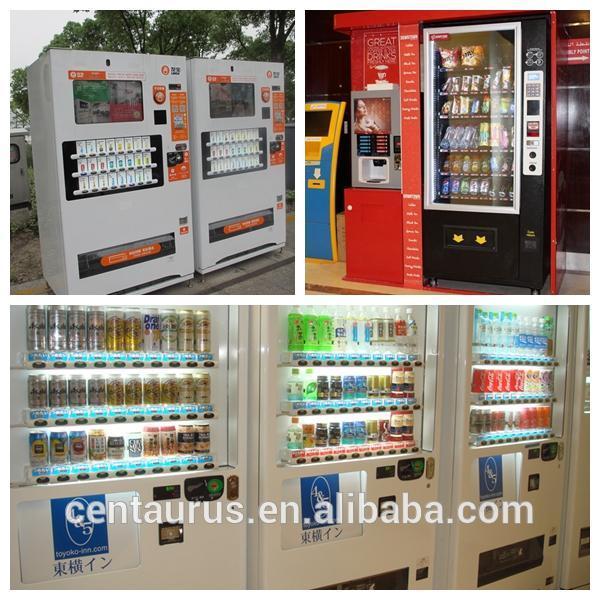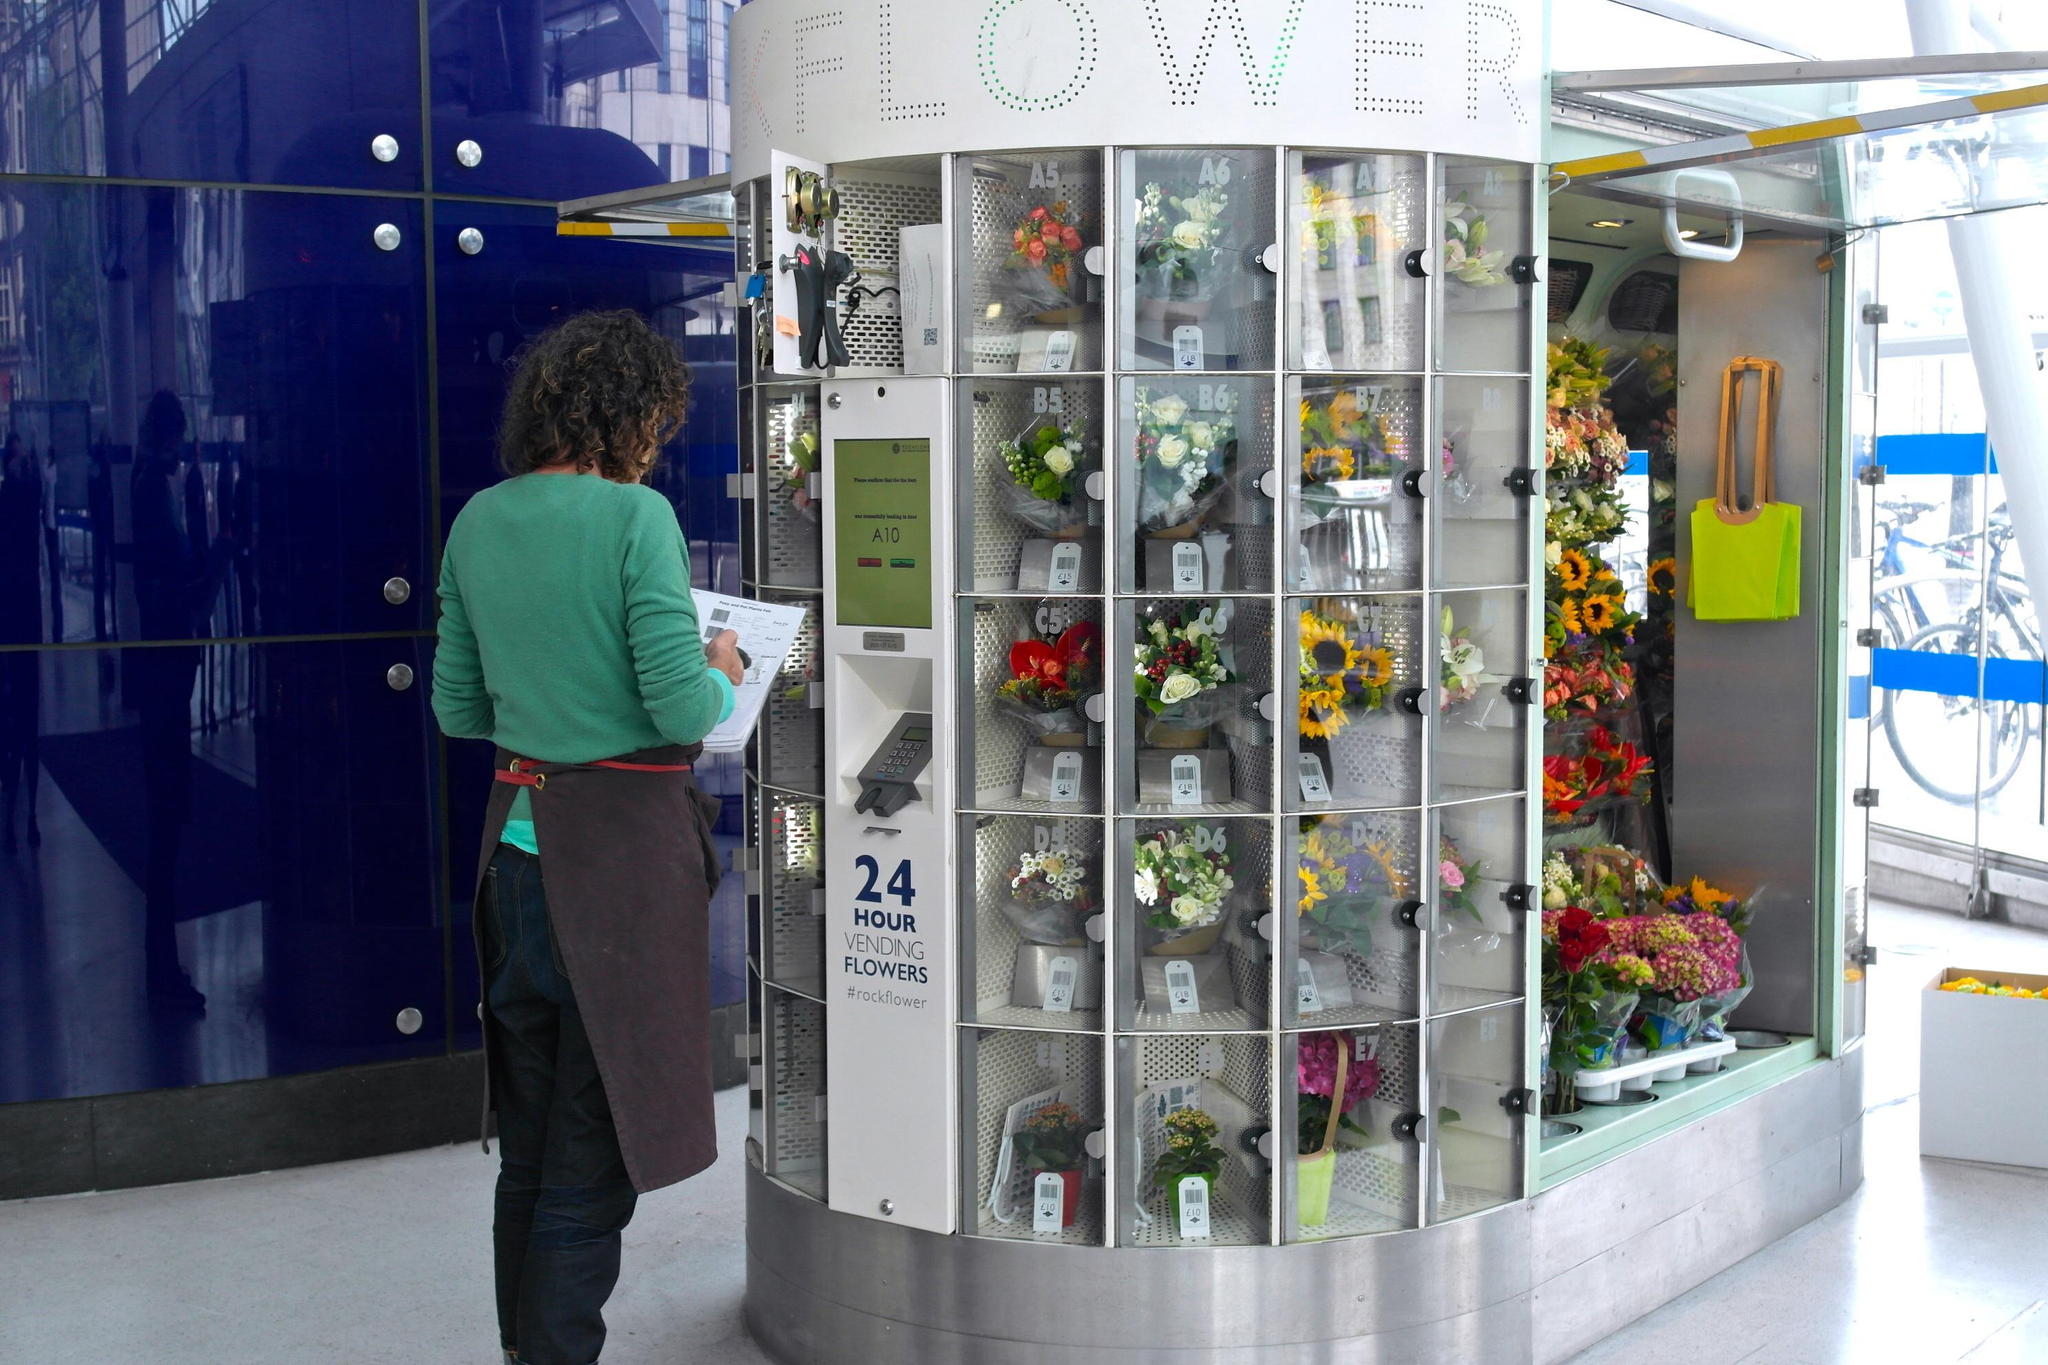The first image is the image on the left, the second image is the image on the right. Analyze the images presented: Is the assertion "There are multiple vending machines, none of which are in restrooms, and there are no people." valid? Answer yes or no. No. The first image is the image on the left, the second image is the image on the right. Given the left and right images, does the statement "Right image includes a white vending machine that dispenses beverages." hold true? Answer yes or no. No. 